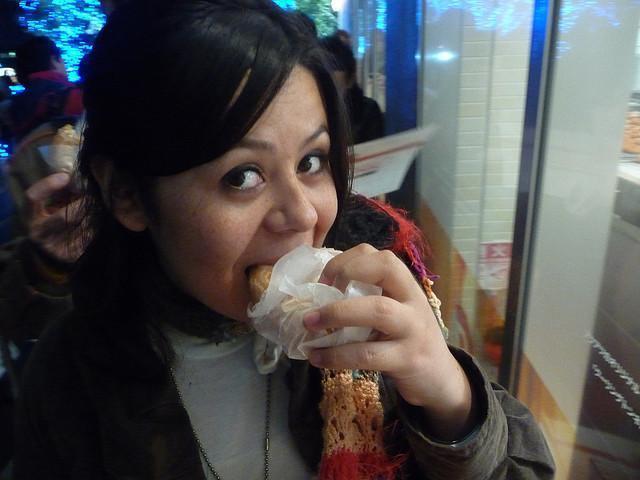How many people are there?
Give a very brief answer. 3. How many oranges are on the counter?
Give a very brief answer. 0. 